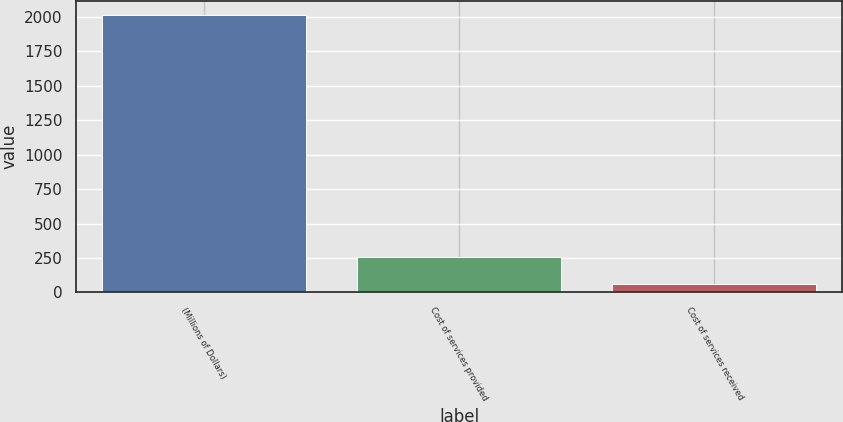Convert chart. <chart><loc_0><loc_0><loc_500><loc_500><bar_chart><fcel>(Millions of Dollars)<fcel>Cost of services provided<fcel>Cost of services received<nl><fcel>2016<fcel>259.2<fcel>64<nl></chart> 